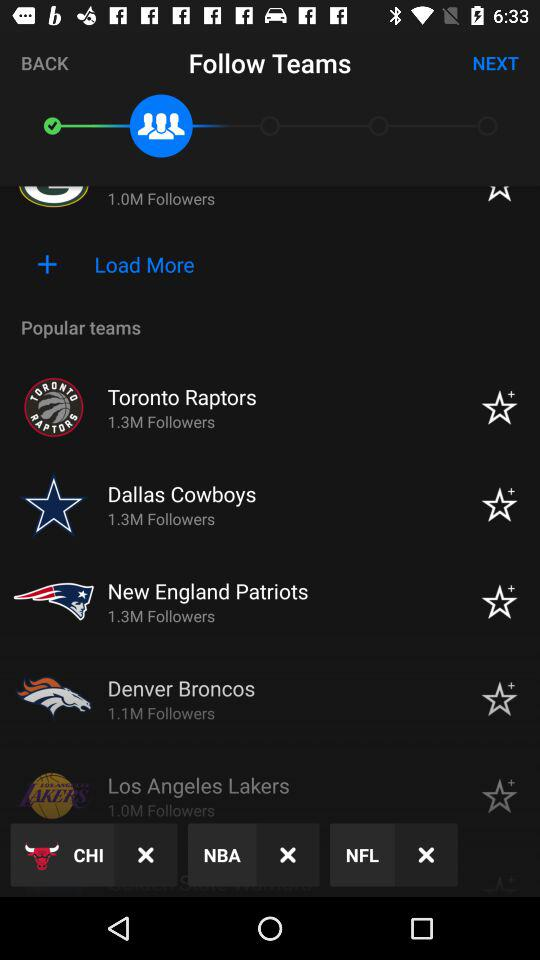Which teams have more followers?
When the provided information is insufficient, respond with <no answer>. <no answer> 